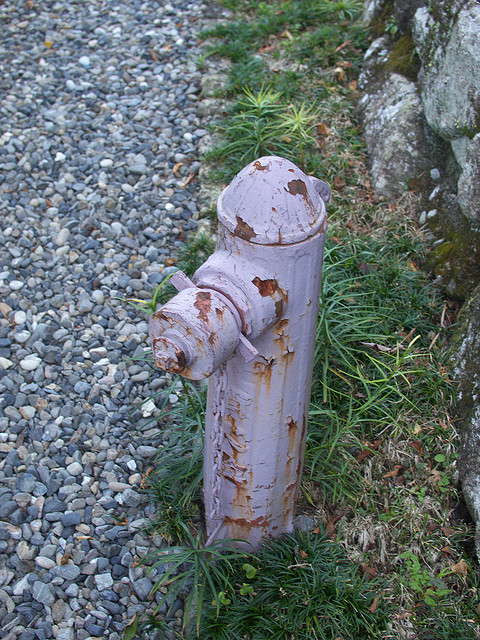What's the main object in the image? The main object in the image is a fireplug, commonly referred to as a fire hydrant. 